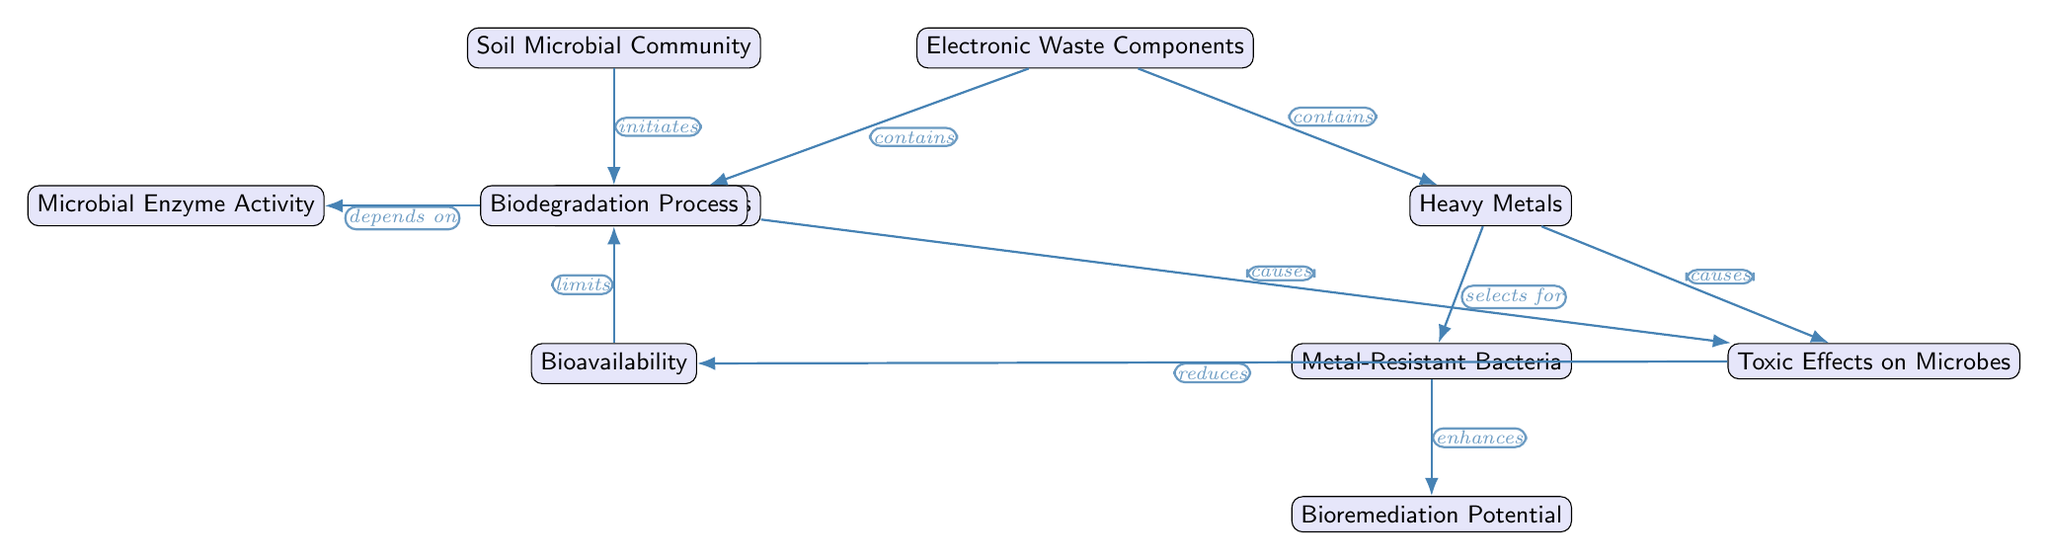What is the main component of the diagram? The main component at the top of the diagram is the "Soil Microbial Community," representing the focus of the study regarding its interactions with electronic waste.
Answer: Soil Microbial Community How many nodes are in the diagram? Counting from the diagram, there are a total of 10 distinct nodes displayed, each representing different elements of the interaction between soil microbes and electronic waste.
Answer: 10 What type of impact do heavy metals have on microbes? The relationship dictated by the diagram indicates that heavy metals cause "Toxic Effects on Microbes," demonstrating a negative consequence of electronic waste on microbial communities.
Answer: Toxic Effects on Microbes What does the Biodegradation Process depend on? The diagram illustrates that the Biodegradation Process is dependent on "Microbial Enzyme Activity." This shows the critical role enzymes play in the degradation process in the presence of pollutants.
Answer: Microbial Enzyme Activity What do organic pollutants cause according to the diagram? The diagram states that organic pollutants cause "Toxic Effects on Microbes," indicating that these pollutants negatively affect the microbial community, similar to heavy metals.
Answer: Toxic Effects on Microbes What is the relationship between metal-resistant bacteria and bioremediation potential? The diagram shows that metal-resistant bacteria enhance the "Bioremediation Potential," meaning that these specialized microbes increase the effectiveness of remediation processes in contaminated soils.
Answer: enhances What limits the biodegradation process as indicated in the diagram? It is shown in the diagram that the availability of nutrients and contaminants, indicated by "Bioavailability," limits the Biodegradation Process, which can hinder microbial activity.
Answer: limits How do heavy metals affect the microbial community's composition? The diagram suggests that heavy metals select for metal-resistant bacteria, indicating that the presence of these metals influences which types of microbes are present in the environment.
Answer: selects for What do heavy metals and organic pollutants have in common according to the diagram? Both heavy metals and organic pollutants cause "Toxic Effects on Microbes," thus illustrating their similar detrimental impacts on soil microbial communities.
Answer: Toxic Effects on Microbes 